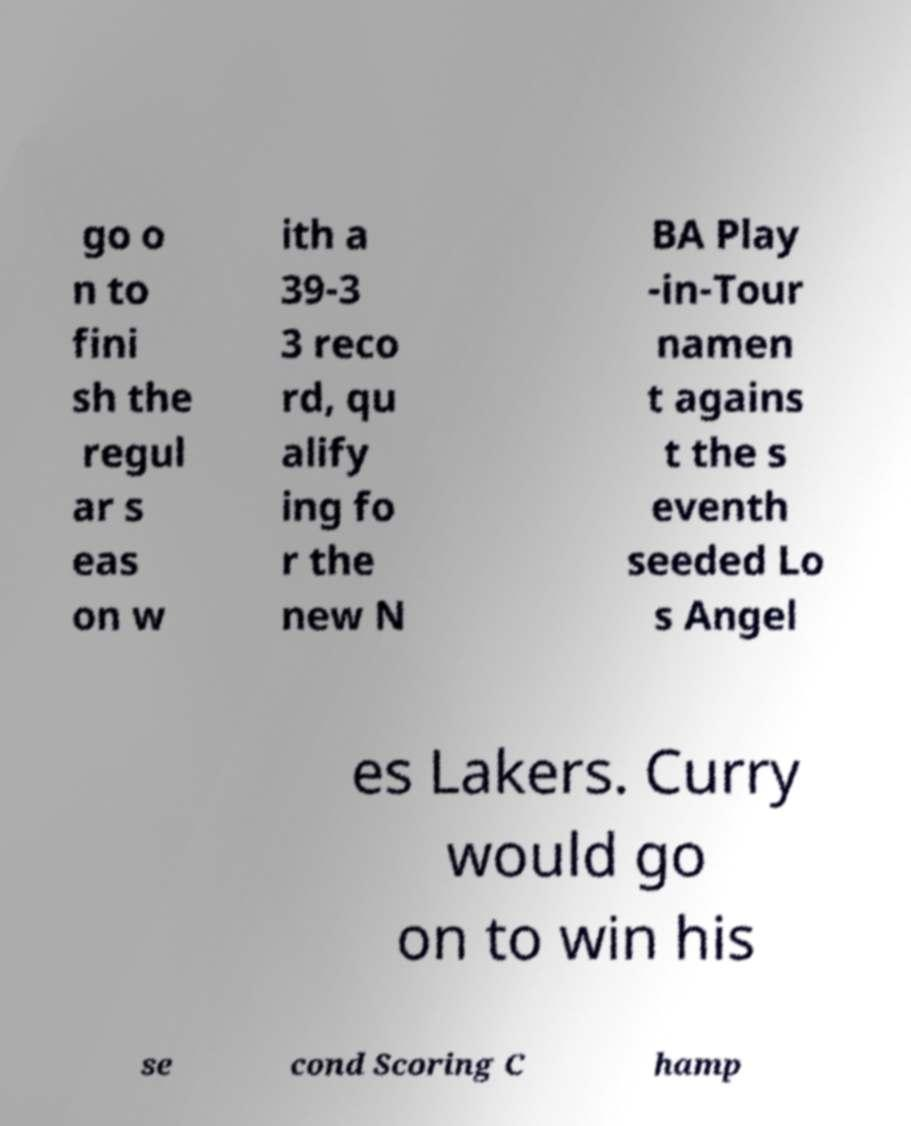Could you extract and type out the text from this image? go o n to fini sh the regul ar s eas on w ith a 39-3 3 reco rd, qu alify ing fo r the new N BA Play -in-Tour namen t agains t the s eventh seeded Lo s Angel es Lakers. Curry would go on to win his se cond Scoring C hamp 